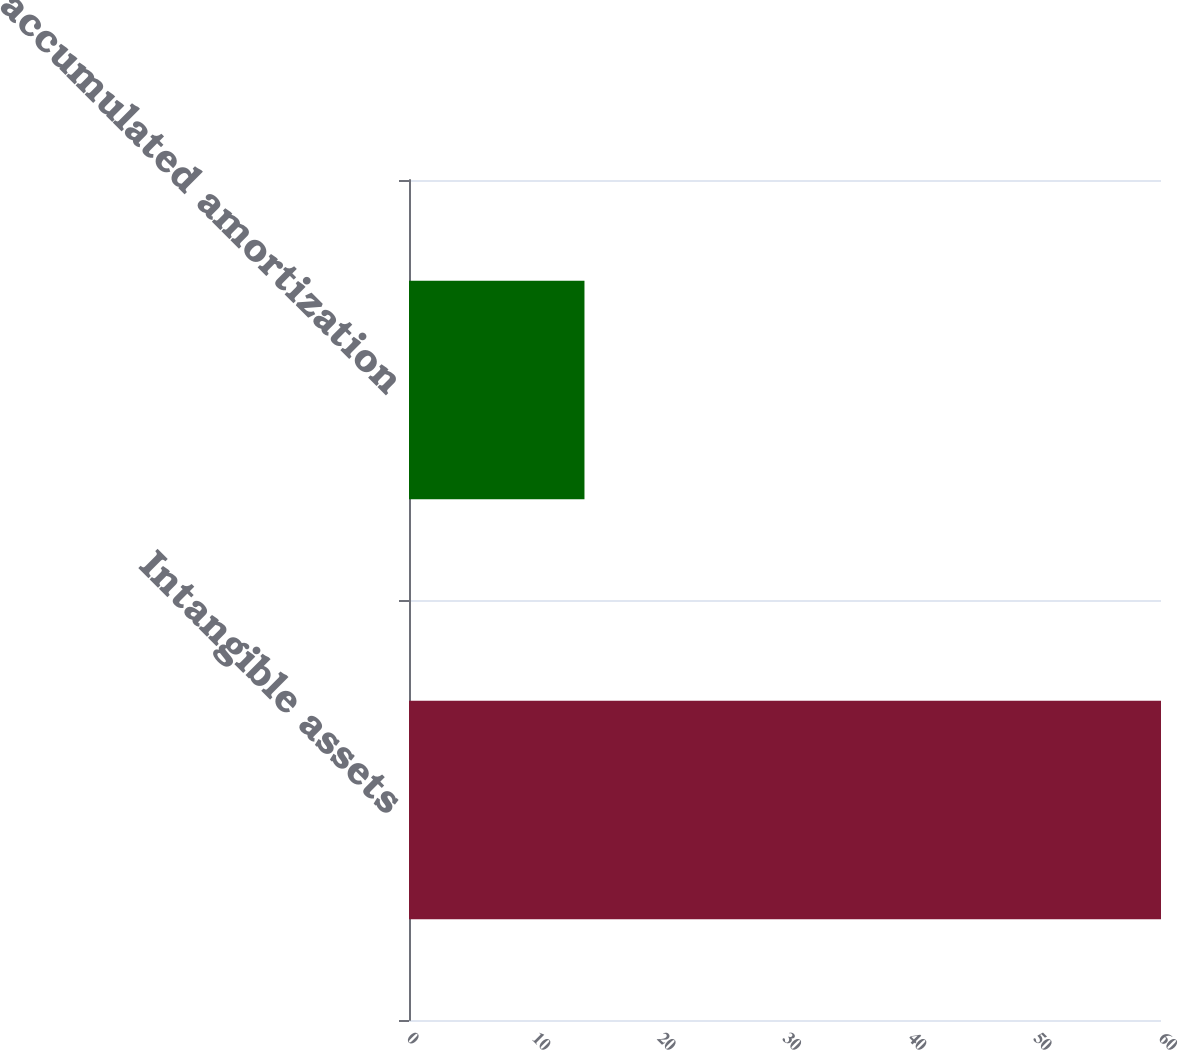Convert chart. <chart><loc_0><loc_0><loc_500><loc_500><bar_chart><fcel>Intangible assets<fcel>Less accumulated amortization<nl><fcel>60<fcel>14<nl></chart> 